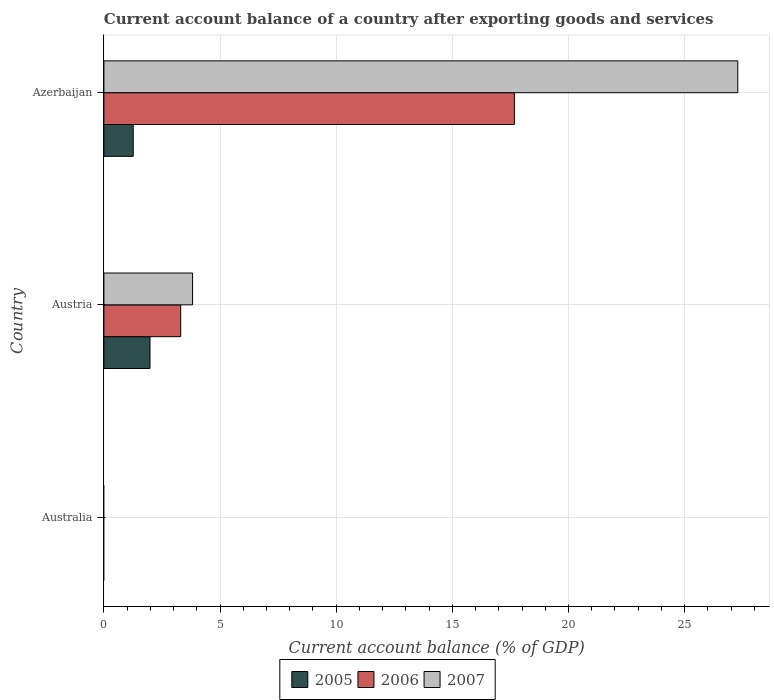Are the number of bars on each tick of the Y-axis equal?
Your answer should be very brief. No. How many bars are there on the 1st tick from the top?
Your answer should be compact. 3. How many bars are there on the 1st tick from the bottom?
Make the answer very short. 0. What is the label of the 3rd group of bars from the top?
Provide a succinct answer. Australia. In how many cases, is the number of bars for a given country not equal to the number of legend labels?
Your answer should be very brief. 1. What is the account balance in 2007 in Austria?
Give a very brief answer. 3.82. Across all countries, what is the maximum account balance in 2007?
Keep it short and to the point. 27.29. Across all countries, what is the minimum account balance in 2006?
Give a very brief answer. 0. In which country was the account balance in 2006 maximum?
Provide a short and direct response. Azerbaijan. What is the total account balance in 2006 in the graph?
Your answer should be compact. 20.98. What is the difference between the account balance in 2006 in Austria and that in Azerbaijan?
Offer a terse response. -14.36. What is the difference between the account balance in 2006 in Azerbaijan and the account balance in 2007 in Australia?
Give a very brief answer. 17.67. What is the average account balance in 2006 per country?
Ensure brevity in your answer.  6.99. What is the difference between the account balance in 2005 and account balance in 2007 in Azerbaijan?
Give a very brief answer. -26.03. In how many countries, is the account balance in 2006 greater than 14 %?
Make the answer very short. 1. What is the difference between the highest and the lowest account balance in 2006?
Offer a very short reply. 17.67. How many bars are there?
Give a very brief answer. 6. Are all the bars in the graph horizontal?
Offer a terse response. Yes. What is the difference between two consecutive major ticks on the X-axis?
Provide a succinct answer. 5. Does the graph contain any zero values?
Your answer should be compact. Yes. Does the graph contain grids?
Offer a terse response. Yes. How are the legend labels stacked?
Keep it short and to the point. Horizontal. What is the title of the graph?
Ensure brevity in your answer.  Current account balance of a country after exporting goods and services. Does "2003" appear as one of the legend labels in the graph?
Ensure brevity in your answer.  No. What is the label or title of the X-axis?
Your response must be concise. Current account balance (% of GDP). What is the label or title of the Y-axis?
Your answer should be very brief. Country. What is the Current account balance (% of GDP) in 2005 in Australia?
Provide a succinct answer. 0. What is the Current account balance (% of GDP) of 2006 in Australia?
Offer a very short reply. 0. What is the Current account balance (% of GDP) in 2007 in Australia?
Give a very brief answer. 0. What is the Current account balance (% of GDP) in 2005 in Austria?
Your answer should be compact. 1.98. What is the Current account balance (% of GDP) in 2006 in Austria?
Offer a terse response. 3.31. What is the Current account balance (% of GDP) in 2007 in Austria?
Make the answer very short. 3.82. What is the Current account balance (% of GDP) in 2005 in Azerbaijan?
Your response must be concise. 1.26. What is the Current account balance (% of GDP) of 2006 in Azerbaijan?
Your response must be concise. 17.67. What is the Current account balance (% of GDP) of 2007 in Azerbaijan?
Offer a terse response. 27.29. Across all countries, what is the maximum Current account balance (% of GDP) in 2005?
Ensure brevity in your answer.  1.98. Across all countries, what is the maximum Current account balance (% of GDP) in 2006?
Provide a succinct answer. 17.67. Across all countries, what is the maximum Current account balance (% of GDP) of 2007?
Make the answer very short. 27.29. What is the total Current account balance (% of GDP) of 2005 in the graph?
Keep it short and to the point. 3.25. What is the total Current account balance (% of GDP) in 2006 in the graph?
Your answer should be very brief. 20.98. What is the total Current account balance (% of GDP) of 2007 in the graph?
Your answer should be compact. 31.11. What is the difference between the Current account balance (% of GDP) in 2005 in Austria and that in Azerbaijan?
Offer a terse response. 0.72. What is the difference between the Current account balance (% of GDP) of 2006 in Austria and that in Azerbaijan?
Ensure brevity in your answer.  -14.36. What is the difference between the Current account balance (% of GDP) of 2007 in Austria and that in Azerbaijan?
Give a very brief answer. -23.47. What is the difference between the Current account balance (% of GDP) in 2005 in Austria and the Current account balance (% of GDP) in 2006 in Azerbaijan?
Make the answer very short. -15.68. What is the difference between the Current account balance (% of GDP) in 2005 in Austria and the Current account balance (% of GDP) in 2007 in Azerbaijan?
Provide a succinct answer. -25.3. What is the difference between the Current account balance (% of GDP) of 2006 in Austria and the Current account balance (% of GDP) of 2007 in Azerbaijan?
Offer a terse response. -23.98. What is the average Current account balance (% of GDP) in 2005 per country?
Your answer should be very brief. 1.08. What is the average Current account balance (% of GDP) of 2006 per country?
Make the answer very short. 6.99. What is the average Current account balance (% of GDP) in 2007 per country?
Ensure brevity in your answer.  10.37. What is the difference between the Current account balance (% of GDP) of 2005 and Current account balance (% of GDP) of 2006 in Austria?
Provide a succinct answer. -1.32. What is the difference between the Current account balance (% of GDP) in 2005 and Current account balance (% of GDP) in 2007 in Austria?
Ensure brevity in your answer.  -1.83. What is the difference between the Current account balance (% of GDP) in 2006 and Current account balance (% of GDP) in 2007 in Austria?
Offer a very short reply. -0.51. What is the difference between the Current account balance (% of GDP) in 2005 and Current account balance (% of GDP) in 2006 in Azerbaijan?
Your answer should be compact. -16.41. What is the difference between the Current account balance (% of GDP) in 2005 and Current account balance (% of GDP) in 2007 in Azerbaijan?
Your answer should be compact. -26.03. What is the difference between the Current account balance (% of GDP) of 2006 and Current account balance (% of GDP) of 2007 in Azerbaijan?
Make the answer very short. -9.62. What is the ratio of the Current account balance (% of GDP) of 2005 in Austria to that in Azerbaijan?
Give a very brief answer. 1.57. What is the ratio of the Current account balance (% of GDP) in 2006 in Austria to that in Azerbaijan?
Offer a terse response. 0.19. What is the ratio of the Current account balance (% of GDP) of 2007 in Austria to that in Azerbaijan?
Make the answer very short. 0.14. What is the difference between the highest and the lowest Current account balance (% of GDP) in 2005?
Ensure brevity in your answer.  1.98. What is the difference between the highest and the lowest Current account balance (% of GDP) of 2006?
Give a very brief answer. 17.67. What is the difference between the highest and the lowest Current account balance (% of GDP) of 2007?
Provide a succinct answer. 27.29. 